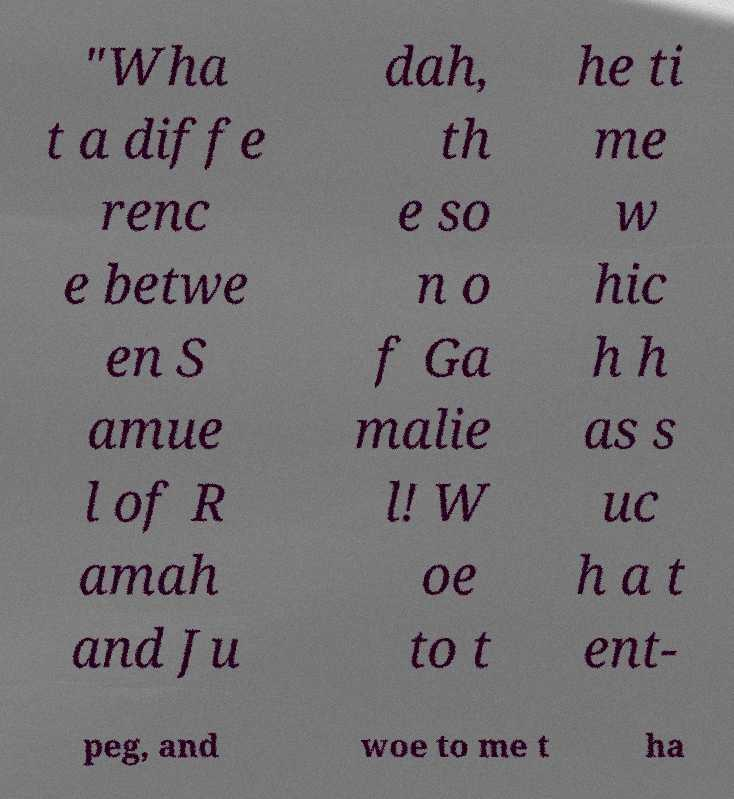For documentation purposes, I need the text within this image transcribed. Could you provide that? "Wha t a diffe renc e betwe en S amue l of R amah and Ju dah, th e so n o f Ga malie l! W oe to t he ti me w hic h h as s uc h a t ent- peg, and woe to me t ha 